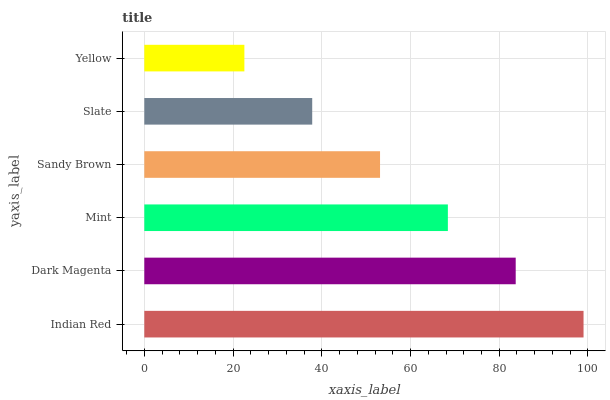Is Yellow the minimum?
Answer yes or no. Yes. Is Indian Red the maximum?
Answer yes or no. Yes. Is Dark Magenta the minimum?
Answer yes or no. No. Is Dark Magenta the maximum?
Answer yes or no. No. Is Indian Red greater than Dark Magenta?
Answer yes or no. Yes. Is Dark Magenta less than Indian Red?
Answer yes or no. Yes. Is Dark Magenta greater than Indian Red?
Answer yes or no. No. Is Indian Red less than Dark Magenta?
Answer yes or no. No. Is Mint the high median?
Answer yes or no. Yes. Is Sandy Brown the low median?
Answer yes or no. Yes. Is Indian Red the high median?
Answer yes or no. No. Is Yellow the low median?
Answer yes or no. No. 